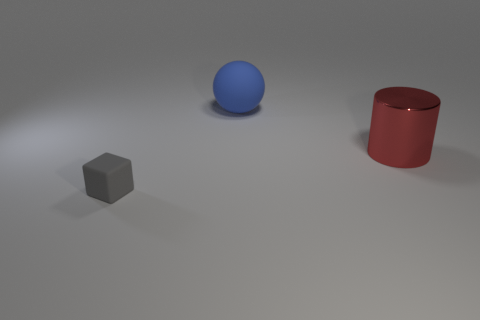Add 1 small things. How many small things are left? 2 Add 1 small gray balls. How many small gray balls exist? 1 Add 3 tiny red matte spheres. How many objects exist? 6 Subtract 0 red balls. How many objects are left? 3 Subtract all cylinders. How many objects are left? 2 Subtract all purple blocks. Subtract all cyan cylinders. How many blocks are left? 1 Subtract all purple balls. How many green cylinders are left? 0 Subtract all gray rubber things. Subtract all big blue balls. How many objects are left? 1 